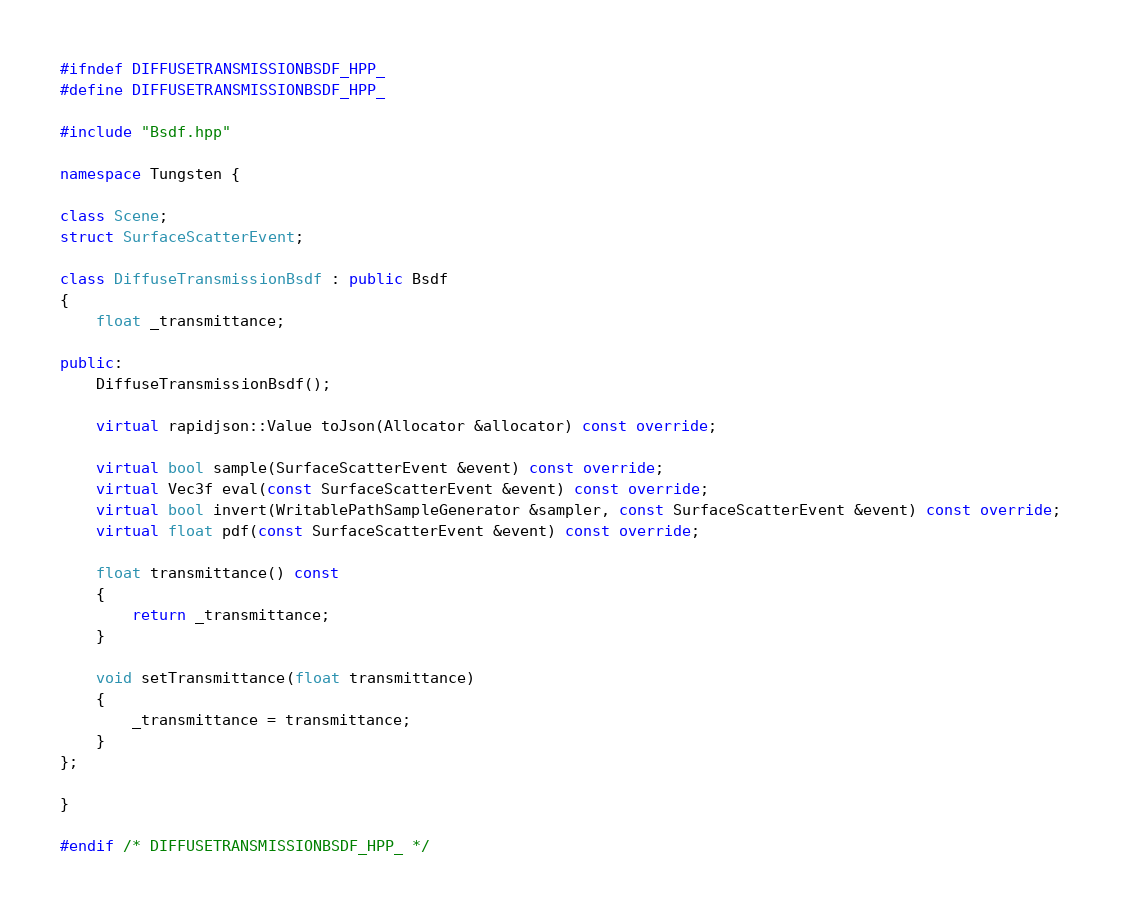Convert code to text. <code><loc_0><loc_0><loc_500><loc_500><_C++_>#ifndef DIFFUSETRANSMISSIONBSDF_HPP_
#define DIFFUSETRANSMISSIONBSDF_HPP_

#include "Bsdf.hpp"

namespace Tungsten {

class Scene;
struct SurfaceScatterEvent;

class DiffuseTransmissionBsdf : public Bsdf
{
    float _transmittance;

public:
    DiffuseTransmissionBsdf();

    virtual rapidjson::Value toJson(Allocator &allocator) const override;

    virtual bool sample(SurfaceScatterEvent &event) const override;
    virtual Vec3f eval(const SurfaceScatterEvent &event) const override;
    virtual bool invert(WritablePathSampleGenerator &sampler, const SurfaceScatterEvent &event) const override;
    virtual float pdf(const SurfaceScatterEvent &event) const override;

    float transmittance() const
    {
        return _transmittance;
    }

    void setTransmittance(float transmittance)
    {
        _transmittance = transmittance;
    }
};

}

#endif /* DIFFUSETRANSMISSIONBSDF_HPP_ */
</code> 